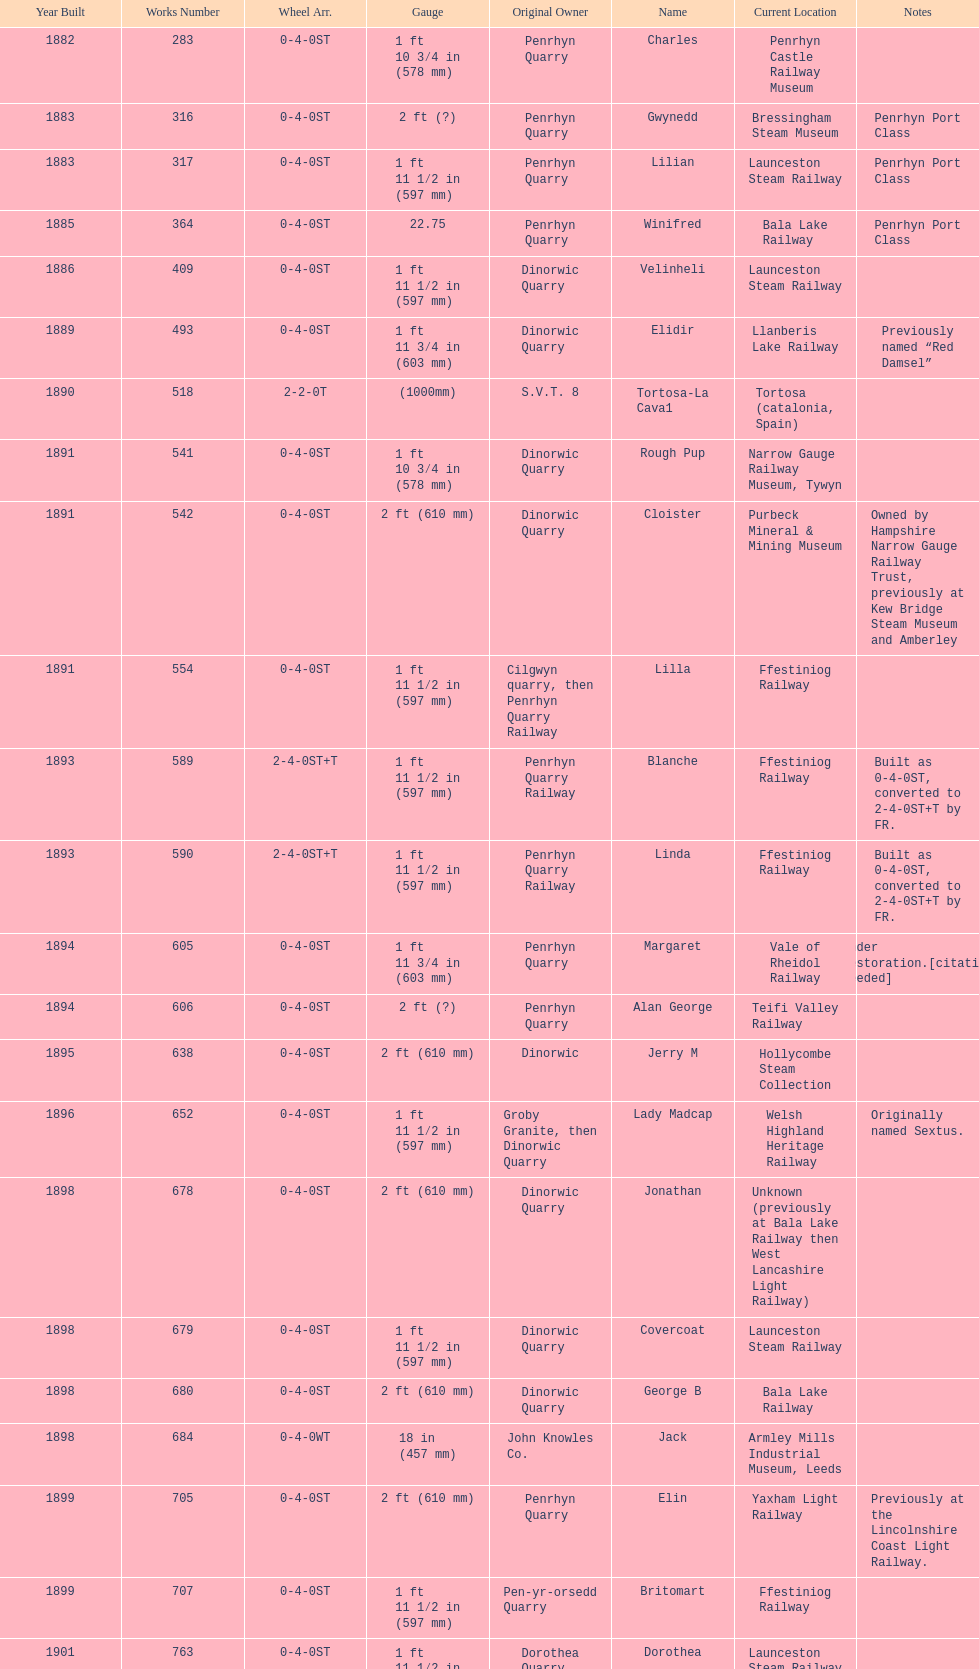Which work number had a larger measurement, 283 or 317? 317. 